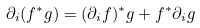Convert formula to latex. <formula><loc_0><loc_0><loc_500><loc_500>\partial _ { i } ( f ^ { * } g ) = ( \partial _ { i } f ) ^ { * } g + f ^ { * } \partial _ { i } g</formula> 